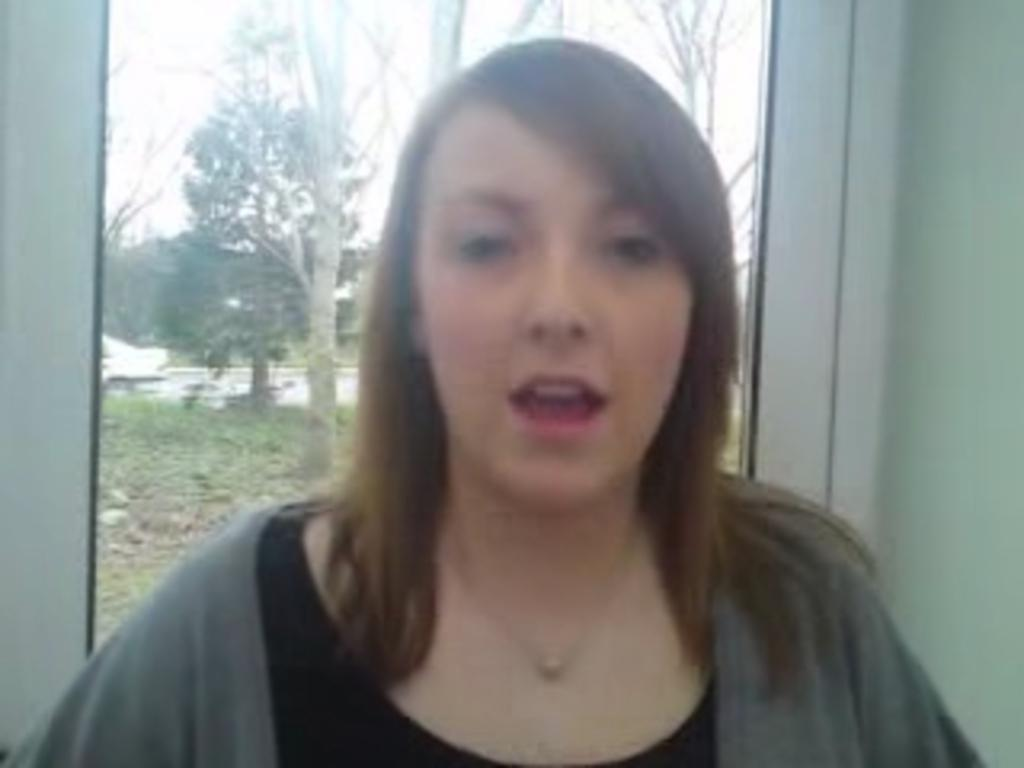Who is present in the image? There is a lady in the image. What is the primary feature of the background? There is a glass window in the image. What can be seen through the window? Trees and the ground are visible outside the window. What type of hobbies does the lady have, as indicated by the presence of a brick in the image? There is no brick present in the image, so it cannot be used to determine the lady's hobbies. 